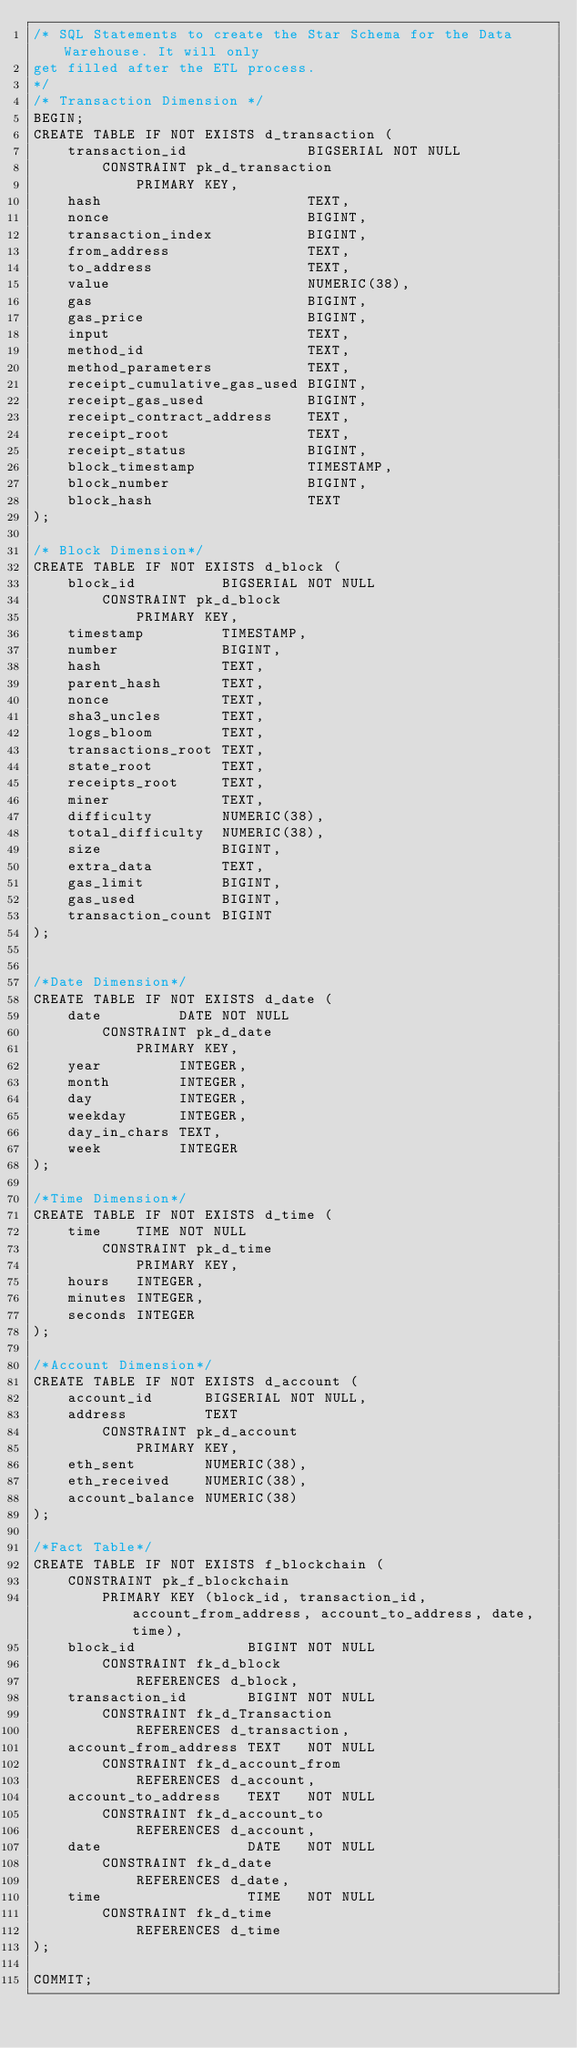<code> <loc_0><loc_0><loc_500><loc_500><_SQL_>/* SQL Statements to create the Star Schema for the Data Warehouse. It will only
get filled after the ETL process.
*/
/* Transaction Dimension */
BEGIN;
CREATE TABLE IF NOT EXISTS d_transaction (
    transaction_id              BIGSERIAL NOT NULL
        CONSTRAINT pk_d_transaction
            PRIMARY KEY,
    hash                        TEXT,
    nonce                       BIGINT,
    transaction_index           BIGINT,
    from_address                TEXT,
    to_address                  TEXT,
    value                       NUMERIC(38),
    gas                         BIGINT,
    gas_price                   BIGINT,
    input                       TEXT,
    method_id                   TEXT,
    method_parameters           TEXT,
    receipt_cumulative_gas_used BIGINT,
    receipt_gas_used            BIGINT,
    receipt_contract_address    TEXT,
    receipt_root                TEXT,
    receipt_status              BIGINT,
    block_timestamp             TIMESTAMP,
    block_number                BIGINT,
    block_hash                  TEXT
);

/* Block Dimension*/
CREATE TABLE IF NOT EXISTS d_block (
    block_id          BIGSERIAL NOT NULL
        CONSTRAINT pk_d_block
            PRIMARY KEY,
    timestamp         TIMESTAMP,
    number            BIGINT,
    hash              TEXT,
    parent_hash       TEXT,
    nonce             TEXT,
    sha3_uncles       TEXT,
    logs_bloom        TEXT,
    transactions_root TEXT,
    state_root        TEXT,
    receipts_root     TEXT,
    miner             TEXT,
    difficulty        NUMERIC(38),
    total_difficulty  NUMERIC(38),
    size              BIGINT,
    extra_data        TEXT,
    gas_limit         BIGINT,
    gas_used          BIGINT,
    transaction_count BIGINT
);


/*Date Dimension*/
CREATE TABLE IF NOT EXISTS d_date (
    date         DATE NOT NULL
        CONSTRAINT pk_d_date
            PRIMARY KEY,
    year         INTEGER,
    month        INTEGER,
    day          INTEGER,
    weekday      INTEGER,
    day_in_chars TEXT,
    week         INTEGER
);

/*Time Dimension*/
CREATE TABLE IF NOT EXISTS d_time (
    time    TIME NOT NULL
        CONSTRAINT pk_d_time
            PRIMARY KEY,
    hours   INTEGER,
    minutes INTEGER,
    seconds INTEGER
);

/*Account Dimension*/
CREATE TABLE IF NOT EXISTS d_account (
    account_id      BIGSERIAL NOT NULL,
    address         TEXT
        CONSTRAINT pk_d_account
            PRIMARY KEY,
    eth_sent        NUMERIC(38),
    eth_received    NUMERIC(38),
    account_balance NUMERIC(38)
);

/*Fact Table*/
CREATE TABLE IF NOT EXISTS f_blockchain (
    CONSTRAINT pk_f_blockchain
        PRIMARY KEY (block_id, transaction_id, account_from_address, account_to_address, date, time),
    block_id             BIGINT NOT NULL
        CONSTRAINT fk_d_block
            REFERENCES d_block,
    transaction_id       BIGINT NOT NULL
        CONSTRAINT fk_d_Transaction
            REFERENCES d_transaction,
    account_from_address TEXT   NOT NULL
        CONSTRAINT fk_d_account_from
            REFERENCES d_account,
    account_to_address   TEXT   NOT NULL
        CONSTRAINT fk_d_account_to
            REFERENCES d_account,
    date                 DATE   NOT NULL
        CONSTRAINT fk_d_date
            REFERENCES d_date,
    time                 TIME   NOT NULL
        CONSTRAINT fk_d_time
            REFERENCES d_time
);

COMMIT;
</code> 